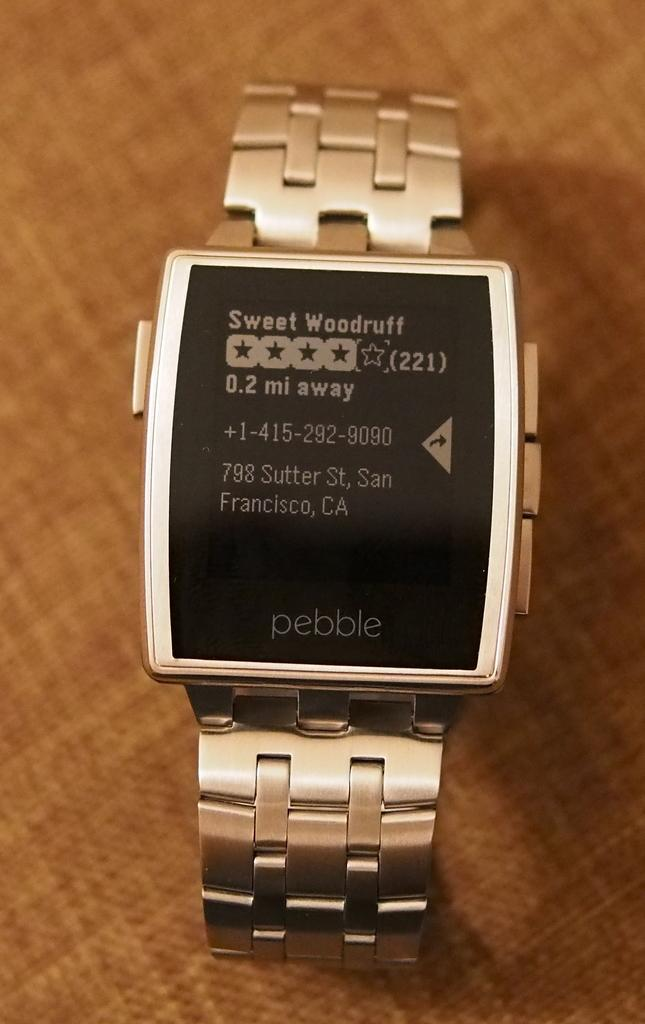<image>
Summarize the visual content of the image. the word pebble is on the silver watch 